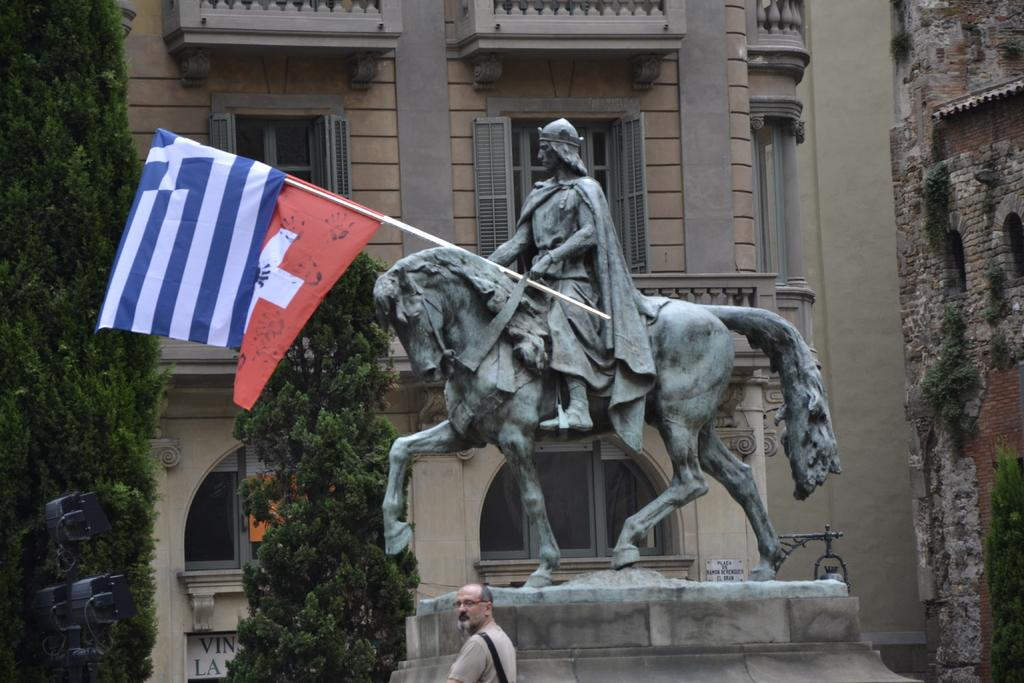What is the main subject in the center of the image? There is a statue in the center of the image. What else can be seen in the image besides the statue? There are flags, a person at the bottom of the image, trees, and buildings in the background of the image. What type of pear is being held by the person in the image? There is no pear present in the image; the person is not holding any fruit. 